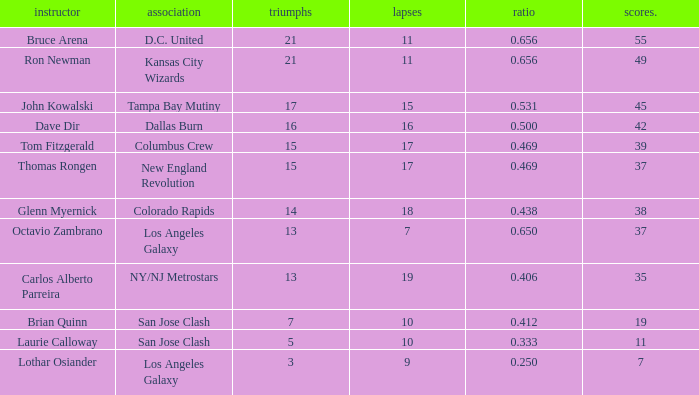What is the highest percent of Bruce Arena when he loses more than 11 games? None. 